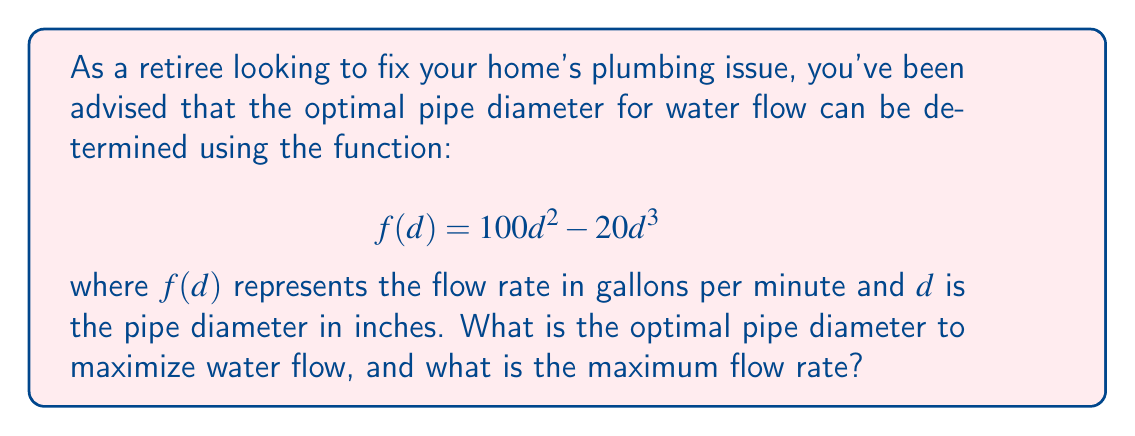Could you help me with this problem? To solve this problem, we need to find the maximum value of the function $f(d) = 100d^2 - 20d^3$. This can be done by following these steps:

1) First, we need to find the derivative of the function:
   $$f'(d) = 200d - 60d^2$$

2) To find the maximum, we set the derivative equal to zero and solve for $d$:
   $$200d - 60d^2 = 0$$
   $$d(200 - 60d) = 0$$
   
   This equation has two solutions: $d = 0$ or $200 - 60d = 0$

3) Solving $200 - 60d = 0$:
   $$-60d = -200$$
   $$d = \frac{10}{3} \approx 3.33$$

4) To confirm this is a maximum (not a minimum), we can check the second derivative:
   $$f''(d) = 200 - 120d$$
   At $d = \frac{10}{3}$, $f''(\frac{10}{3}) = 200 - 120(\frac{10}{3}) = -200 < 0$
   
   Since the second derivative is negative at this point, we confirm it's a maximum.

5) To find the maximum flow rate, we substitute $d = \frac{10}{3}$ into the original function:
   $$f(\frac{10}{3}) = 100(\frac{10}{3})^2 - 20(\frac{10}{3})^3$$
   $$= 100(\frac{100}{9}) - 20(\frac{1000}{27})$$
   $$= \frac{10000}{9} - \frac{20000}{27} = \frac{30000}{27} - \frac{20000}{27} = \frac{10000}{27} \approx 370.37$$

Therefore, the optimal pipe diameter is $\frac{10}{3}$ inches (approximately 3.33 inches), and the maximum flow rate is $\frac{10000}{27}$ gallons per minute (approximately 370.37 gallons per minute).
Answer: The optimal pipe diameter is $\frac{10}{3}$ inches (≈ 3.33 inches), and the maximum flow rate is $\frac{10000}{27}$ gallons per minute (≈ 370.37 gallons per minute). 